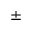<formula> <loc_0><loc_0><loc_500><loc_500>\pm</formula> 